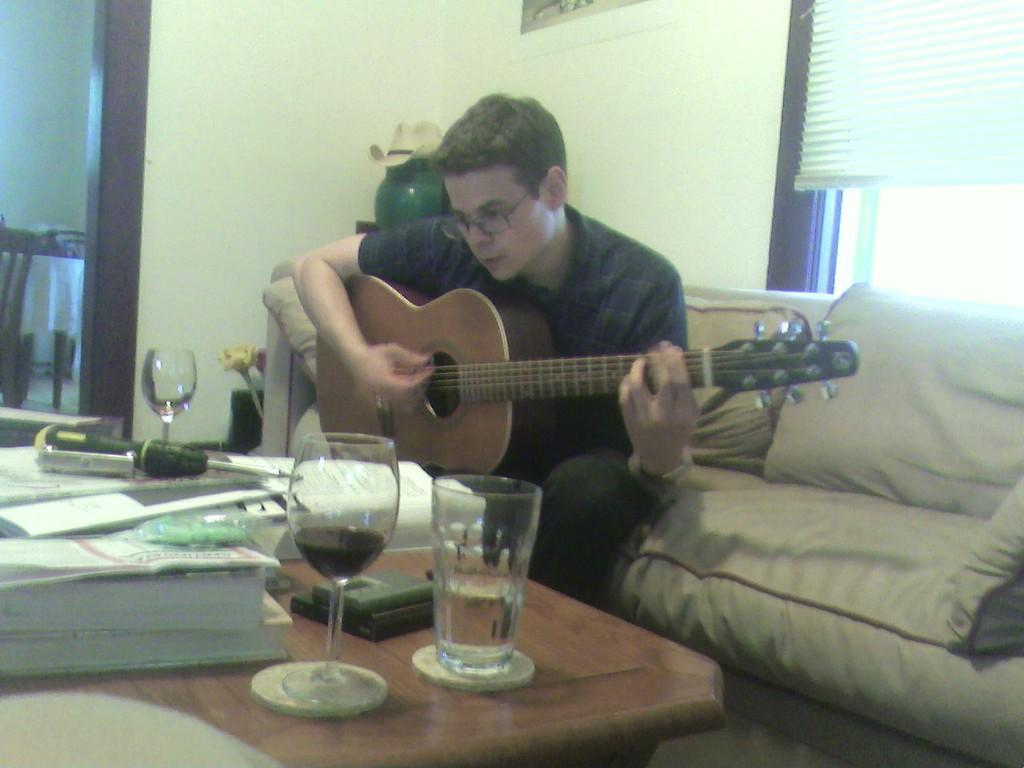How would you summarize this image in a sentence or two? A man is sitting on a sofa and he playing guitar and there are some pillows. In front of him there is a table. On that table there is a glass, a tool, books, papers. Behind him there is a window. 